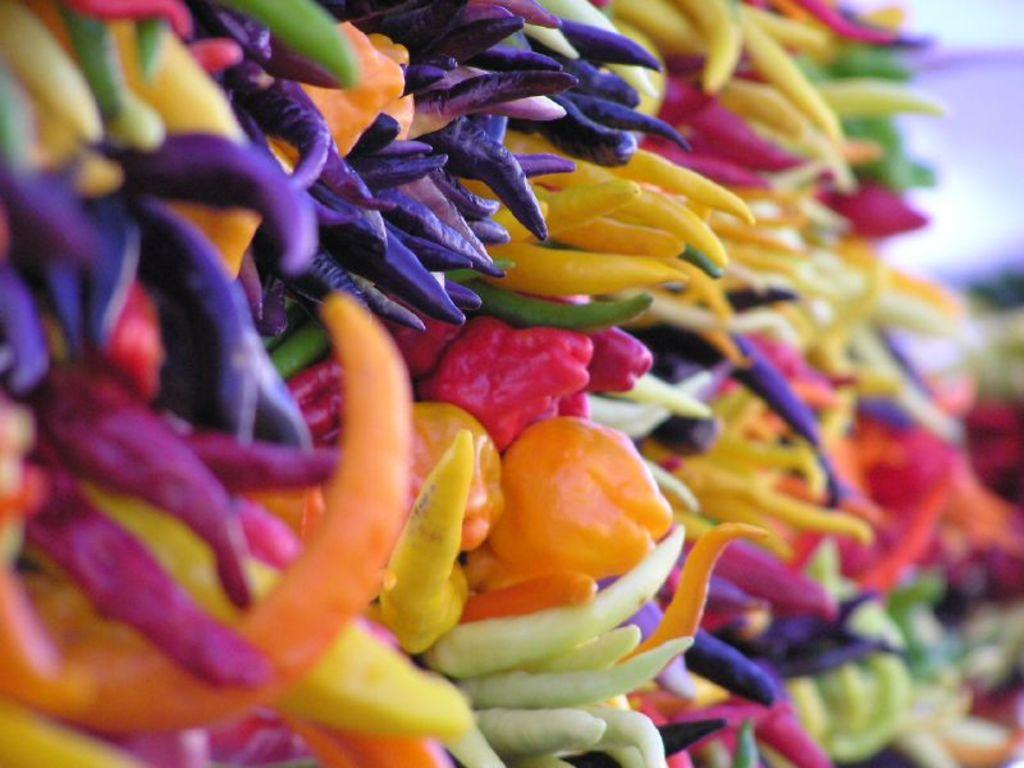What type of food items are present in the image? There are chilies of different colors in the image. Can you describe the colors of the chilies? The chilies in the image have different colors. What might be a common use for these chilies in cooking? Chilies are often used to add spice and flavor to dishes. Is there a mailbox in the image with a letter inside? No, there is no mailbox or letter present in the image; it only contains chilies of different colors. 